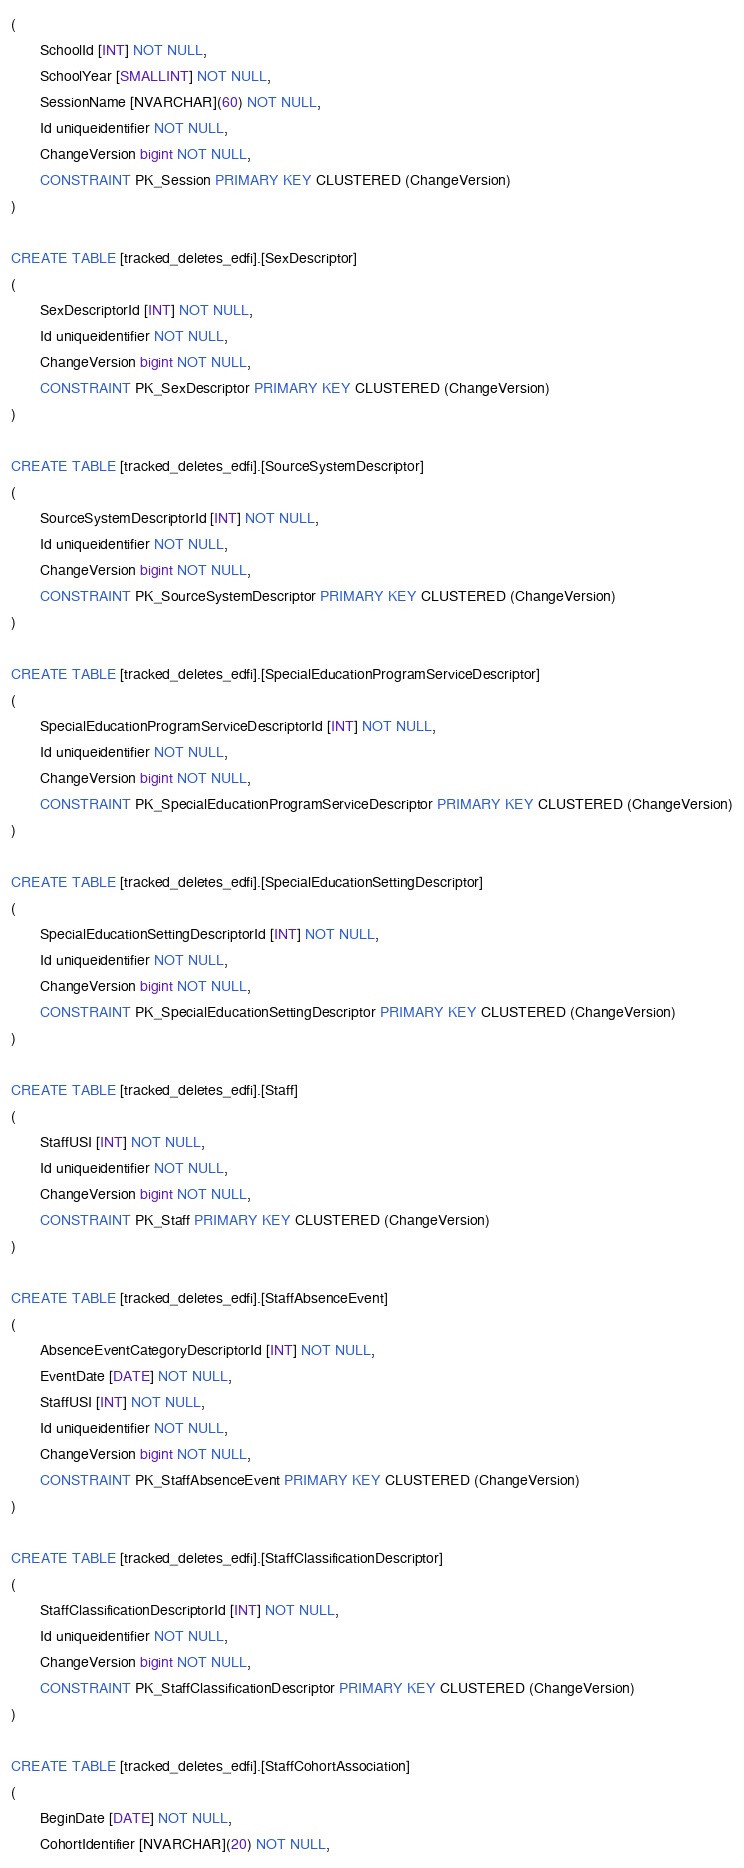<code> <loc_0><loc_0><loc_500><loc_500><_SQL_>(
       SchoolId [INT] NOT NULL,
       SchoolYear [SMALLINT] NOT NULL,
       SessionName [NVARCHAR](60) NOT NULL,
       Id uniqueidentifier NOT NULL,
       ChangeVersion bigint NOT NULL,
       CONSTRAINT PK_Session PRIMARY KEY CLUSTERED (ChangeVersion)
)

CREATE TABLE [tracked_deletes_edfi].[SexDescriptor]
(
       SexDescriptorId [INT] NOT NULL,
       Id uniqueidentifier NOT NULL,
       ChangeVersion bigint NOT NULL,
       CONSTRAINT PK_SexDescriptor PRIMARY KEY CLUSTERED (ChangeVersion)
)

CREATE TABLE [tracked_deletes_edfi].[SourceSystemDescriptor]
(
       SourceSystemDescriptorId [INT] NOT NULL,
       Id uniqueidentifier NOT NULL,
       ChangeVersion bigint NOT NULL,
       CONSTRAINT PK_SourceSystemDescriptor PRIMARY KEY CLUSTERED (ChangeVersion)
)

CREATE TABLE [tracked_deletes_edfi].[SpecialEducationProgramServiceDescriptor]
(
       SpecialEducationProgramServiceDescriptorId [INT] NOT NULL,
       Id uniqueidentifier NOT NULL,
       ChangeVersion bigint NOT NULL,
       CONSTRAINT PK_SpecialEducationProgramServiceDescriptor PRIMARY KEY CLUSTERED (ChangeVersion)
)

CREATE TABLE [tracked_deletes_edfi].[SpecialEducationSettingDescriptor]
(
       SpecialEducationSettingDescriptorId [INT] NOT NULL,
       Id uniqueidentifier NOT NULL,
       ChangeVersion bigint NOT NULL,
       CONSTRAINT PK_SpecialEducationSettingDescriptor PRIMARY KEY CLUSTERED (ChangeVersion)
)

CREATE TABLE [tracked_deletes_edfi].[Staff]
(
       StaffUSI [INT] NOT NULL,
       Id uniqueidentifier NOT NULL,
       ChangeVersion bigint NOT NULL,
       CONSTRAINT PK_Staff PRIMARY KEY CLUSTERED (ChangeVersion)
)

CREATE TABLE [tracked_deletes_edfi].[StaffAbsenceEvent]
(
       AbsenceEventCategoryDescriptorId [INT] NOT NULL,
       EventDate [DATE] NOT NULL,
       StaffUSI [INT] NOT NULL,
       Id uniqueidentifier NOT NULL,
       ChangeVersion bigint NOT NULL,
       CONSTRAINT PK_StaffAbsenceEvent PRIMARY KEY CLUSTERED (ChangeVersion)
)

CREATE TABLE [tracked_deletes_edfi].[StaffClassificationDescriptor]
(
       StaffClassificationDescriptorId [INT] NOT NULL,
       Id uniqueidentifier NOT NULL,
       ChangeVersion bigint NOT NULL,
       CONSTRAINT PK_StaffClassificationDescriptor PRIMARY KEY CLUSTERED (ChangeVersion)
)

CREATE TABLE [tracked_deletes_edfi].[StaffCohortAssociation]
(
       BeginDate [DATE] NOT NULL,
       CohortIdentifier [NVARCHAR](20) NOT NULL,</code> 